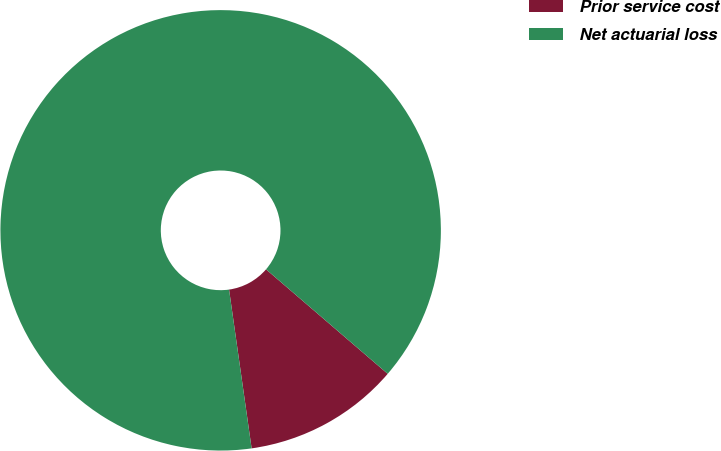Convert chart. <chart><loc_0><loc_0><loc_500><loc_500><pie_chart><fcel>Prior service cost<fcel>Net actuarial loss<nl><fcel>11.46%<fcel>88.54%<nl></chart> 